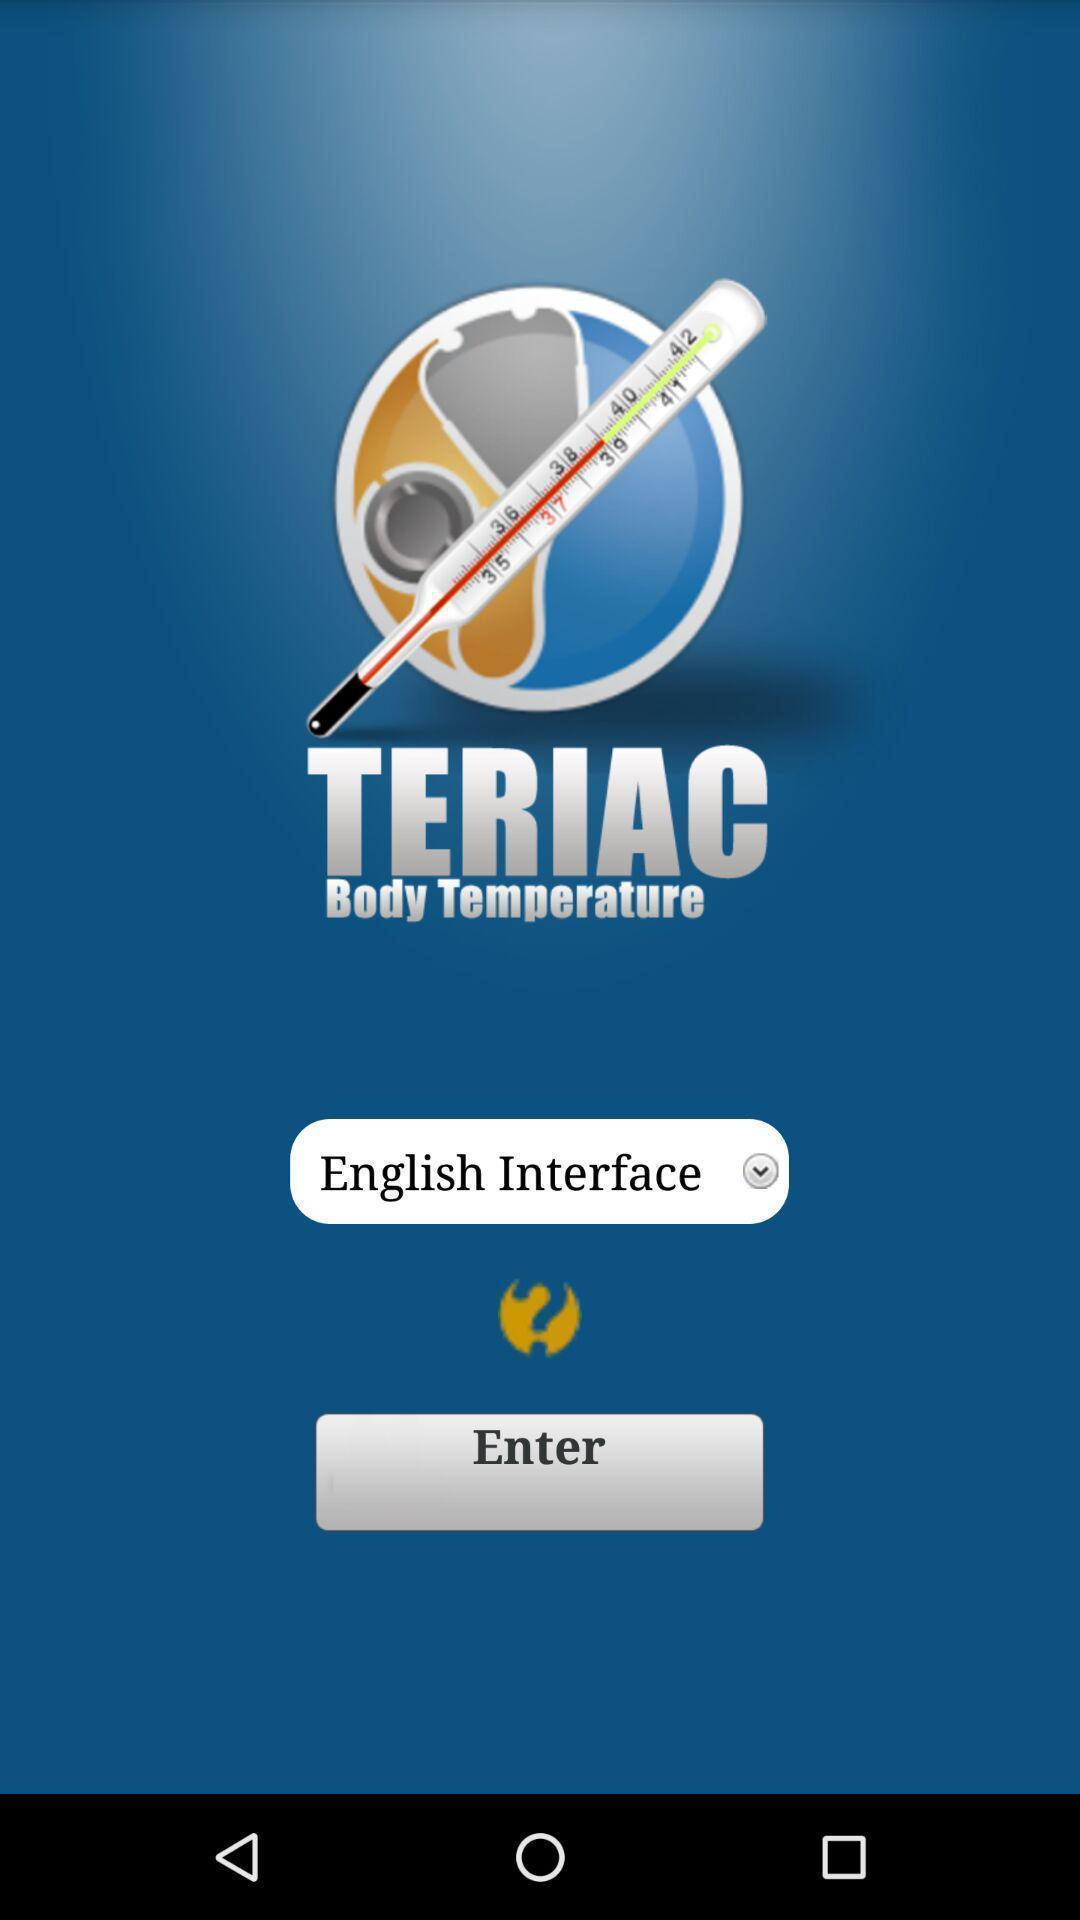What can you discern from this picture? Screen displaying home page. 